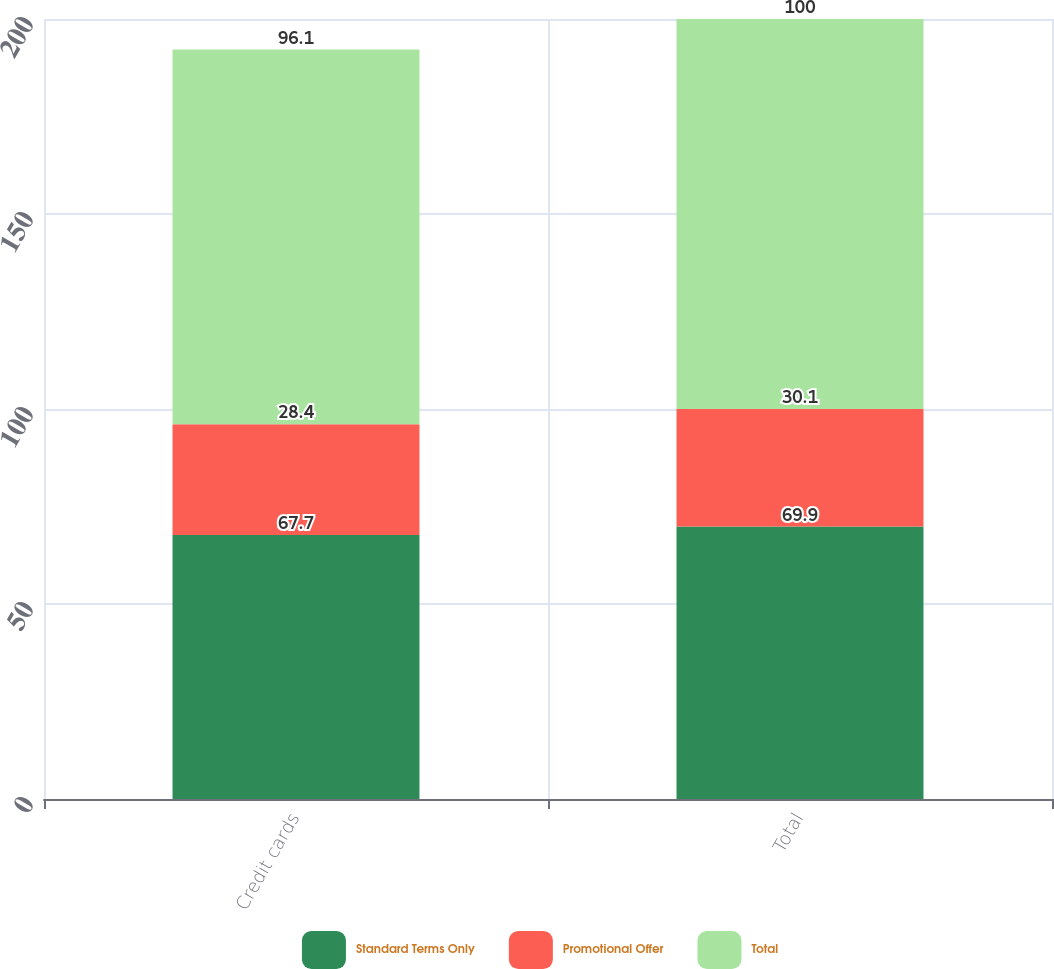Convert chart. <chart><loc_0><loc_0><loc_500><loc_500><stacked_bar_chart><ecel><fcel>Credit cards<fcel>Total<nl><fcel>Standard Terms Only<fcel>67.7<fcel>69.9<nl><fcel>Promotional Offer<fcel>28.4<fcel>30.1<nl><fcel>Total<fcel>96.1<fcel>100<nl></chart> 